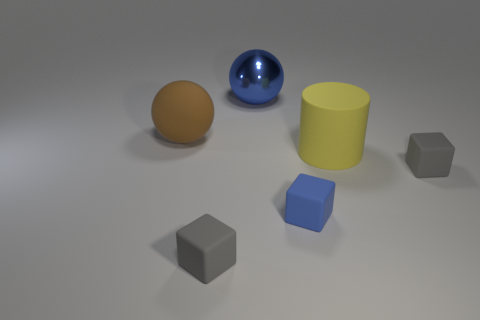Add 2 small rubber blocks. How many objects exist? 8 Subtract all spheres. How many objects are left? 4 Subtract 0 green cylinders. How many objects are left? 6 Subtract all small blue cubes. Subtract all big brown spheres. How many objects are left? 4 Add 2 tiny blue objects. How many tiny blue objects are left? 3 Add 6 large brown matte things. How many large brown matte things exist? 7 